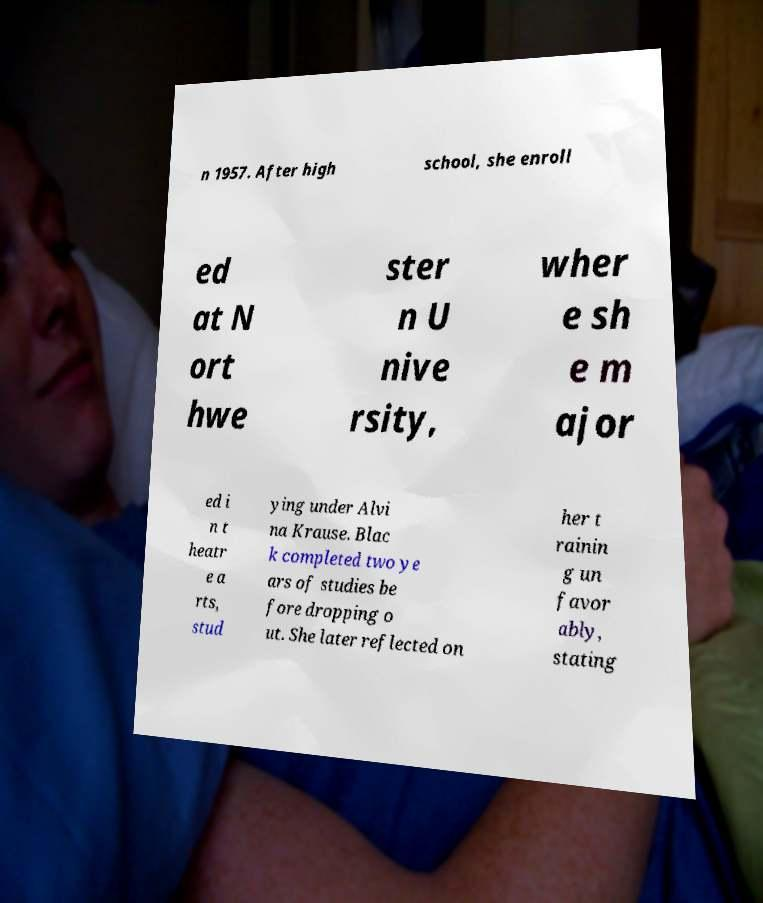Please read and relay the text visible in this image. What does it say? n 1957. After high school, she enroll ed at N ort hwe ster n U nive rsity, wher e sh e m ajor ed i n t heatr e a rts, stud ying under Alvi na Krause. Blac k completed two ye ars of studies be fore dropping o ut. She later reflected on her t rainin g un favor ably, stating 